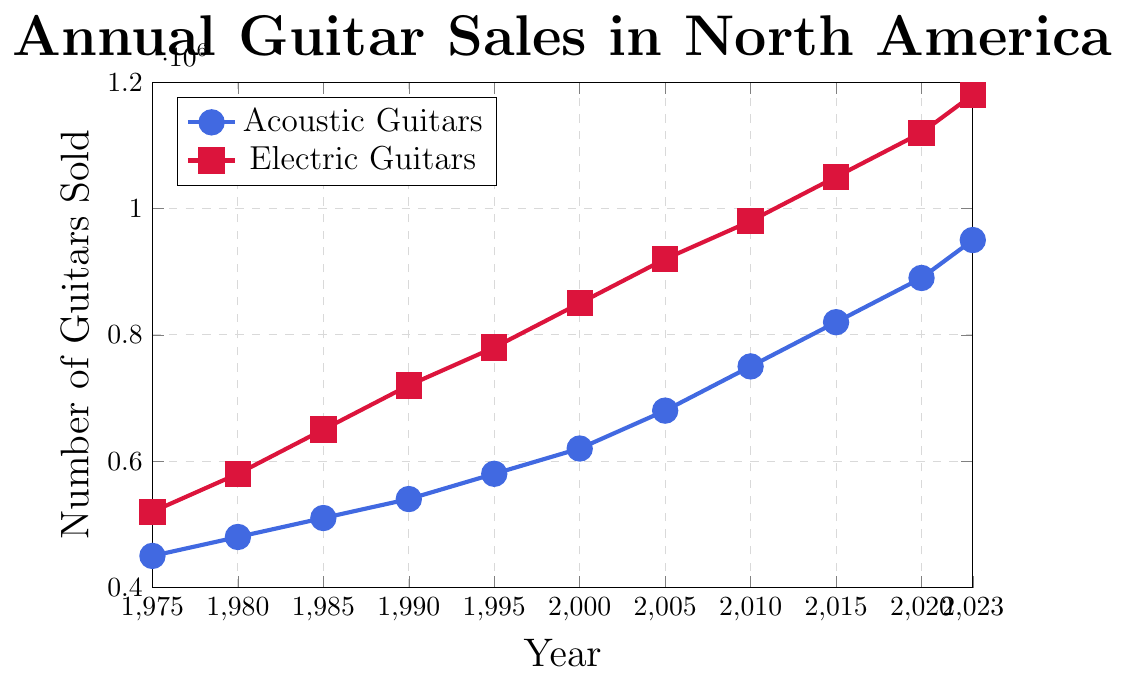When was the first year that the sales of acoustic guitars surpassed 600,000? In the plot, the sales of acoustic guitars cross the 600,000 mark between the years 1995 and 2000. Checking these years, we see the sales were 620,000 in 2000, so the first year over 600,000 was 2000.
Answer: 2000 Which type of guitar had higher sales in 1985? Looking at the plot for the year 1985, the sales of acoustic guitars were 510,000 and electric guitars were 650,000. The sales of electric guitars were higher.
Answer: Electric guitars By how much did the sales of electric guitars increase from 1975 to 2000? The sales of electric guitars in 1975 were 520,000, and in 2000 they were 850,000. Subtracting these numbers gives the increase: 850,000 - 520,000 = 330,000.
Answer: 330,000 What is the difference in the estimated sales between acoustic and electric guitars in 2023? In 2023, the sales of acoustic guitars were 950,000 and electric guitars were 1,180,000. Subtracting the sales of acoustic guitars from electric guitars: 1,180,000 - 950,000 = 230,000.
Answer: 230,000 Which type of guitar showed a steadier increase in sales over the years observed? By examining the plot, acoustic guitar sales increase more steadily and gradually without sharp jumps compared to electric guitar sales, which show bigger increments over shorter periods.
Answer: Acoustic guitars What was the average annual sales of electric guitars from 1975 to 2023? Summing all sales of electric guitars from 1975 to 2023: 520,000 + 580,000 + 650,000 + 720,000 + 780,000 + 850,000 + 920,000 + 980,000 + 1,050,000 + 1,120,000 + 1,180,000 = 9,348,000. Dividing by the number of years (11 data points): 9,348,000 / 11 ≈ 849,818.18.
Answer: 849,818.18 During which decade did the acoustic guitar sales grow the fastest? Checking the plot for each decade, the greatest visual increase is from 2000 to 2010. Acoustic guitar sales go from 620,000 in 2000 to 750,000 in 2010, a significant increase for one decade.
Answer: 2000-2010 Between 2010 and 2020, by what percentage did the sales of acoustic guitars increase? The sales in 2010 were 750,000 and in 2020 they were 890,000. The percentage increase is ((890,000 - 750,000) / 750,000) * 100 = 18.67%.
Answer: 18.67% 